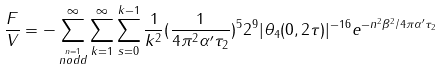<formula> <loc_0><loc_0><loc_500><loc_500>\frac { F } { V } = - \sum _ { \stackrel { n = 1 } { n o d d } } ^ { \infty } \sum _ { k = 1 } ^ { \infty } \sum _ { s = 0 } ^ { k - 1 } \frac { 1 } { k ^ { 2 } } ( \frac { 1 } { 4 \pi ^ { 2 } \alpha ^ { \prime } \tau _ { 2 } } ) ^ { 5 } 2 ^ { 9 } | \theta _ { 4 } ( 0 , 2 \tau ) | ^ { - 1 6 } e ^ { - n ^ { 2 } \beta ^ { 2 } / 4 \pi \alpha ^ { \prime } \tau _ { 2 } }</formula> 